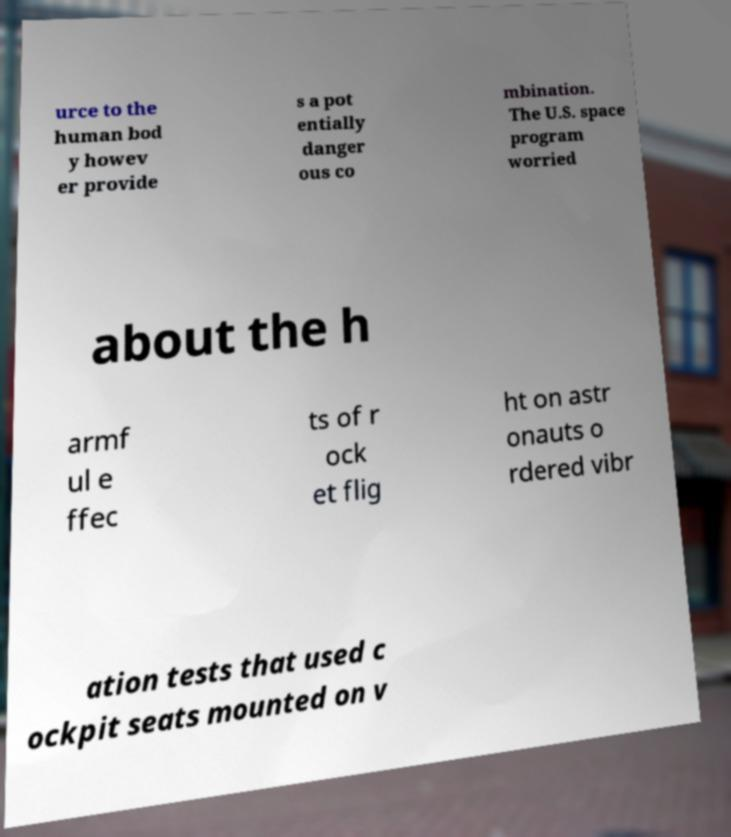There's text embedded in this image that I need extracted. Can you transcribe it verbatim? urce to the human bod y howev er provide s a pot entially danger ous co mbination. The U.S. space program worried about the h armf ul e ffec ts of r ock et flig ht on astr onauts o rdered vibr ation tests that used c ockpit seats mounted on v 